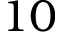Convert formula to latex. <formula><loc_0><loc_0><loc_500><loc_500>1 0</formula> 